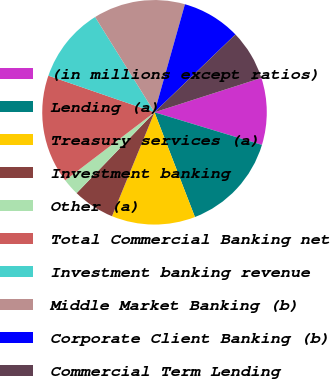<chart> <loc_0><loc_0><loc_500><loc_500><pie_chart><fcel>(in millions except ratios)<fcel>Lending (a)<fcel>Treasury services (a)<fcel>Investment banking<fcel>Other (a)<fcel>Total Commercial Banking net<fcel>Investment banking revenue<fcel>Middle Market Banking (b)<fcel>Corporate Client Banking (b)<fcel>Commercial Term Lending<nl><fcel>9.64%<fcel>14.45%<fcel>12.04%<fcel>6.03%<fcel>2.43%<fcel>15.65%<fcel>10.84%<fcel>13.24%<fcel>8.44%<fcel>7.24%<nl></chart> 